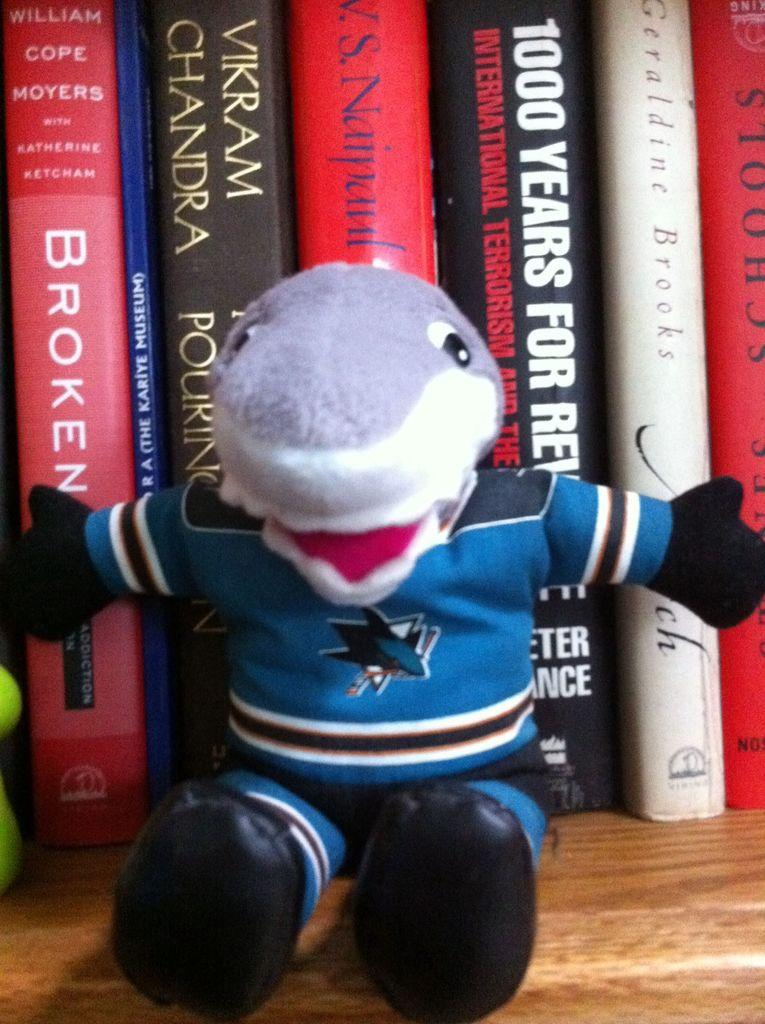<image>
Describe the image concisely. a shark mascot in front of books like Broken 